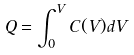Convert formula to latex. <formula><loc_0><loc_0><loc_500><loc_500>Q = \int _ { 0 } ^ { V } C ( V ) d V</formula> 